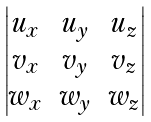<formula> <loc_0><loc_0><loc_500><loc_500>\begin{vmatrix} u _ { x } & u _ { y } & u _ { z } \\ v _ { x } & v _ { y } & v _ { z } \\ w _ { x } & w _ { y } & w _ { z } \end{vmatrix}</formula> 